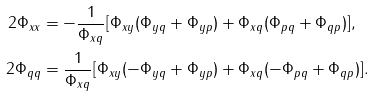<formula> <loc_0><loc_0><loc_500><loc_500>2 \Phi _ { x x } & = - \frac { 1 } { \Phi _ { x q } } [ \Phi _ { x y } ( \Phi _ { y q } + \Phi _ { y p } ) + \Phi _ { x q } ( \Phi _ { p q } + \Phi _ { q p } ) ] , \\ 2 \Phi _ { q q } & = \frac { 1 } { \Phi _ { x q } } [ \Phi _ { x y } ( - \Phi _ { y q } + \Phi _ { y p } ) + \Phi _ { x q } ( - \Phi _ { p q } + \Phi _ { q p } ) ] .</formula> 